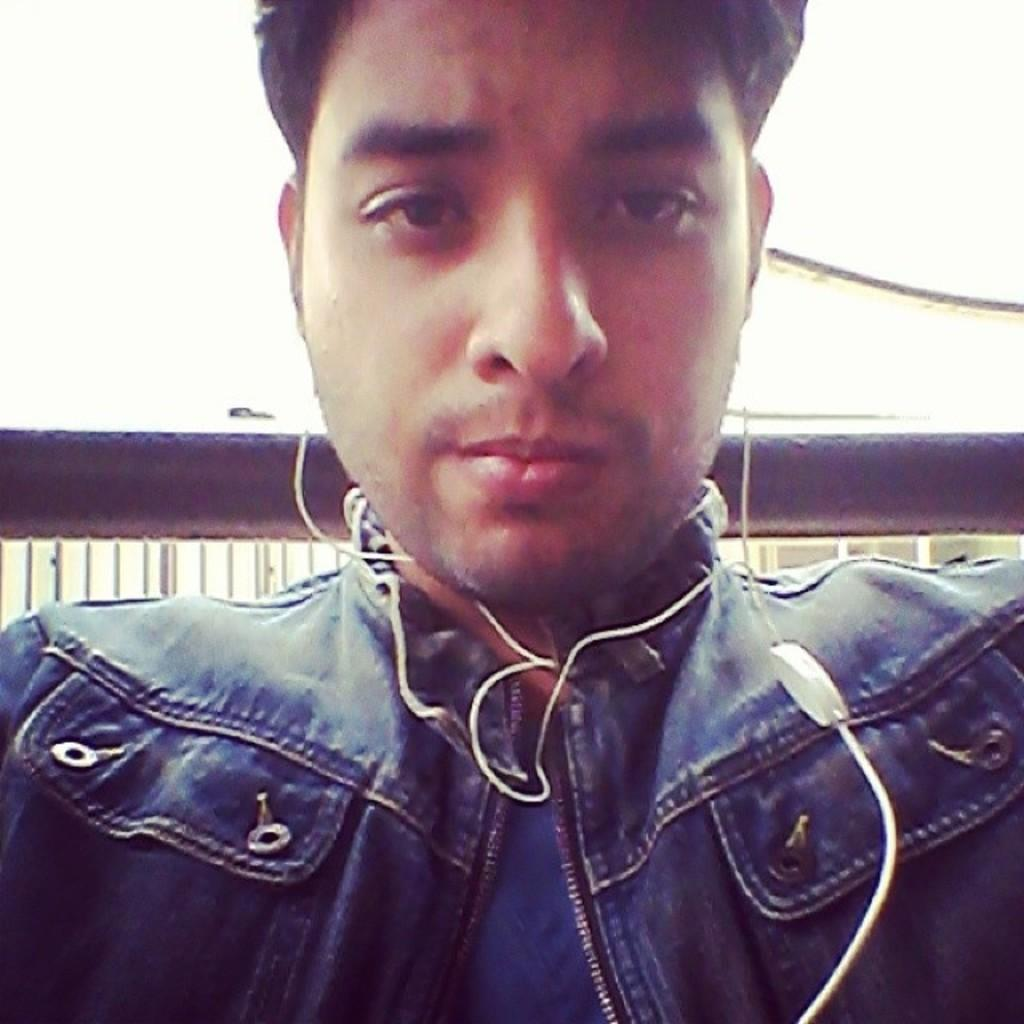Who or what is present in the image? There is a person in the image. What is the person wearing? The person is wearing earphones. Can you describe the background of the image? There is an object in the background of the image. How many ducks are resting on the person's shoulder in the image? There are no ducks present in the image, and therefore no ducks are resting on the person's shoulder. 